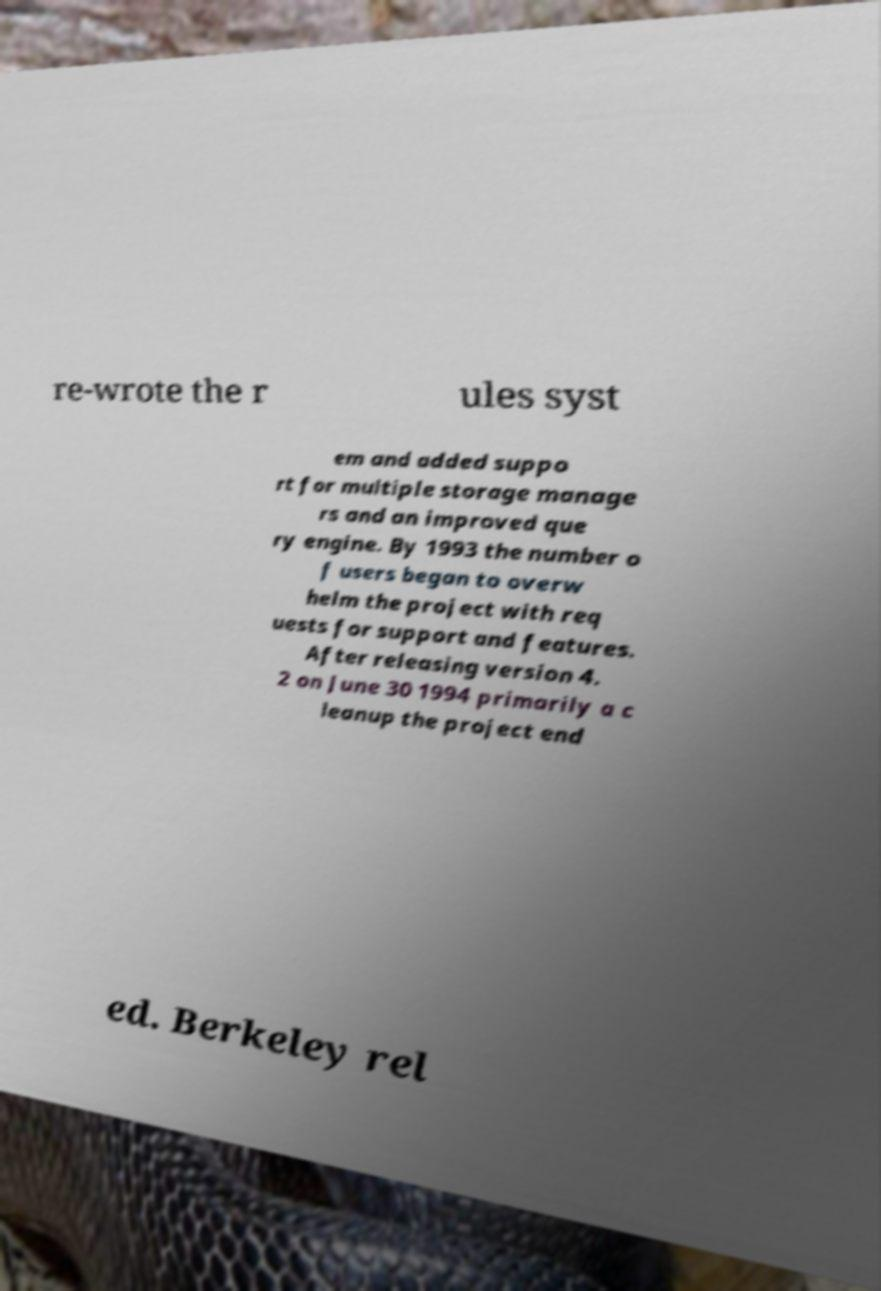Could you extract and type out the text from this image? re-wrote the r ules syst em and added suppo rt for multiple storage manage rs and an improved que ry engine. By 1993 the number o f users began to overw helm the project with req uests for support and features. After releasing version 4. 2 on June 30 1994 primarily a c leanup the project end ed. Berkeley rel 